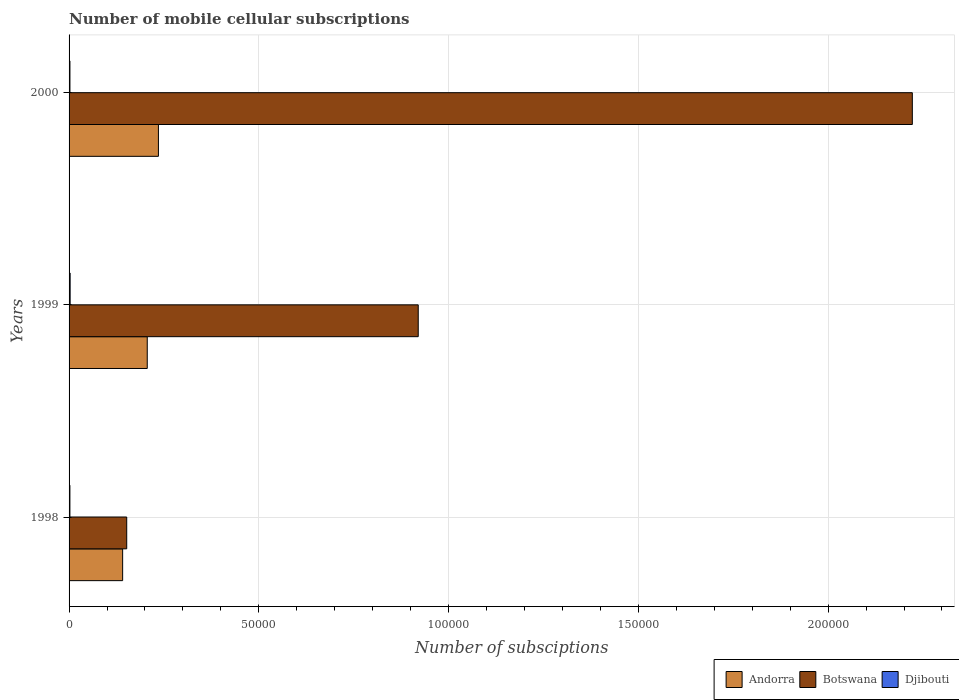How many groups of bars are there?
Your answer should be very brief. 3. What is the label of the 3rd group of bars from the top?
Make the answer very short. 1998. In how many cases, is the number of bars for a given year not equal to the number of legend labels?
Make the answer very short. 0. What is the number of mobile cellular subscriptions in Botswana in 1998?
Your answer should be very brief. 1.52e+04. Across all years, what is the maximum number of mobile cellular subscriptions in Botswana?
Your answer should be compact. 2.22e+05. Across all years, what is the minimum number of mobile cellular subscriptions in Botswana?
Make the answer very short. 1.52e+04. What is the total number of mobile cellular subscriptions in Botswana in the graph?
Your response must be concise. 3.29e+05. What is the difference between the number of mobile cellular subscriptions in Djibouti in 1998 and that in 2000?
Your response must be concise. -10. What is the difference between the number of mobile cellular subscriptions in Andorra in 2000 and the number of mobile cellular subscriptions in Djibouti in 1998?
Provide a short and direct response. 2.33e+04. What is the average number of mobile cellular subscriptions in Botswana per year?
Provide a short and direct response. 1.10e+05. In the year 2000, what is the difference between the number of mobile cellular subscriptions in Djibouti and number of mobile cellular subscriptions in Botswana?
Provide a short and direct response. -2.22e+05. What is the ratio of the number of mobile cellular subscriptions in Andorra in 1998 to that in 2000?
Ensure brevity in your answer.  0.6. Is the difference between the number of mobile cellular subscriptions in Djibouti in 1998 and 1999 greater than the difference between the number of mobile cellular subscriptions in Botswana in 1998 and 1999?
Provide a short and direct response. Yes. What is the difference between the highest and the second highest number of mobile cellular subscriptions in Botswana?
Give a very brief answer. 1.30e+05. What is the difference between the highest and the lowest number of mobile cellular subscriptions in Botswana?
Your response must be concise. 2.07e+05. What does the 3rd bar from the top in 2000 represents?
Offer a terse response. Andorra. What does the 1st bar from the bottom in 1999 represents?
Your response must be concise. Andorra. What is the difference between two consecutive major ticks on the X-axis?
Offer a terse response. 5.00e+04. Are the values on the major ticks of X-axis written in scientific E-notation?
Provide a short and direct response. No. What is the title of the graph?
Ensure brevity in your answer.  Number of mobile cellular subscriptions. What is the label or title of the X-axis?
Provide a succinct answer. Number of subsciptions. What is the Number of subsciptions of Andorra in 1998?
Your answer should be very brief. 1.41e+04. What is the Number of subsciptions of Botswana in 1998?
Offer a terse response. 1.52e+04. What is the Number of subsciptions in Djibouti in 1998?
Offer a terse response. 220. What is the Number of subsciptions in Andorra in 1999?
Provide a short and direct response. 2.06e+04. What is the Number of subsciptions in Botswana in 1999?
Your answer should be very brief. 9.20e+04. What is the Number of subsciptions of Djibouti in 1999?
Make the answer very short. 280. What is the Number of subsciptions in Andorra in 2000?
Make the answer very short. 2.35e+04. What is the Number of subsciptions of Botswana in 2000?
Offer a terse response. 2.22e+05. What is the Number of subsciptions of Djibouti in 2000?
Offer a terse response. 230. Across all years, what is the maximum Number of subsciptions in Andorra?
Give a very brief answer. 2.35e+04. Across all years, what is the maximum Number of subsciptions of Botswana?
Your response must be concise. 2.22e+05. Across all years, what is the maximum Number of subsciptions in Djibouti?
Provide a succinct answer. 280. Across all years, what is the minimum Number of subsciptions of Andorra?
Your answer should be very brief. 1.41e+04. Across all years, what is the minimum Number of subsciptions in Botswana?
Give a very brief answer. 1.52e+04. Across all years, what is the minimum Number of subsciptions in Djibouti?
Provide a short and direct response. 220. What is the total Number of subsciptions in Andorra in the graph?
Offer a very short reply. 5.83e+04. What is the total Number of subsciptions of Botswana in the graph?
Offer a terse response. 3.29e+05. What is the total Number of subsciptions of Djibouti in the graph?
Offer a very short reply. 730. What is the difference between the Number of subsciptions of Andorra in 1998 and that in 1999?
Ensure brevity in your answer.  -6483. What is the difference between the Number of subsciptions of Botswana in 1998 and that in 1999?
Your answer should be very brief. -7.68e+04. What is the difference between the Number of subsciptions of Djibouti in 1998 and that in 1999?
Provide a short and direct response. -60. What is the difference between the Number of subsciptions in Andorra in 1998 and that in 2000?
Your answer should be very brief. -9426. What is the difference between the Number of subsciptions of Botswana in 1998 and that in 2000?
Offer a very short reply. -2.07e+05. What is the difference between the Number of subsciptions in Andorra in 1999 and that in 2000?
Your answer should be compact. -2943. What is the difference between the Number of subsciptions of Botswana in 1999 and that in 2000?
Offer a very short reply. -1.30e+05. What is the difference between the Number of subsciptions of Djibouti in 1999 and that in 2000?
Offer a terse response. 50. What is the difference between the Number of subsciptions of Andorra in 1998 and the Number of subsciptions of Botswana in 1999?
Make the answer very short. -7.79e+04. What is the difference between the Number of subsciptions in Andorra in 1998 and the Number of subsciptions in Djibouti in 1999?
Your answer should be compact. 1.38e+04. What is the difference between the Number of subsciptions of Botswana in 1998 and the Number of subsciptions of Djibouti in 1999?
Make the answer very short. 1.49e+04. What is the difference between the Number of subsciptions of Andorra in 1998 and the Number of subsciptions of Botswana in 2000?
Give a very brief answer. -2.08e+05. What is the difference between the Number of subsciptions in Andorra in 1998 and the Number of subsciptions in Djibouti in 2000?
Your response must be concise. 1.39e+04. What is the difference between the Number of subsciptions of Botswana in 1998 and the Number of subsciptions of Djibouti in 2000?
Offer a very short reply. 1.50e+04. What is the difference between the Number of subsciptions of Andorra in 1999 and the Number of subsciptions of Botswana in 2000?
Your answer should be very brief. -2.02e+05. What is the difference between the Number of subsciptions of Andorra in 1999 and the Number of subsciptions of Djibouti in 2000?
Provide a short and direct response. 2.04e+04. What is the difference between the Number of subsciptions of Botswana in 1999 and the Number of subsciptions of Djibouti in 2000?
Give a very brief answer. 9.18e+04. What is the average Number of subsciptions in Andorra per year?
Provide a short and direct response. 1.94e+04. What is the average Number of subsciptions of Botswana per year?
Your answer should be very brief. 1.10e+05. What is the average Number of subsciptions in Djibouti per year?
Offer a very short reply. 243.33. In the year 1998, what is the difference between the Number of subsciptions of Andorra and Number of subsciptions of Botswana?
Keep it short and to the point. -1073. In the year 1998, what is the difference between the Number of subsciptions of Andorra and Number of subsciptions of Djibouti?
Offer a terse response. 1.39e+04. In the year 1998, what is the difference between the Number of subsciptions of Botswana and Number of subsciptions of Djibouti?
Provide a short and direct response. 1.50e+04. In the year 1999, what is the difference between the Number of subsciptions of Andorra and Number of subsciptions of Botswana?
Your answer should be compact. -7.14e+04. In the year 1999, what is the difference between the Number of subsciptions of Andorra and Number of subsciptions of Djibouti?
Offer a very short reply. 2.03e+04. In the year 1999, what is the difference between the Number of subsciptions in Botswana and Number of subsciptions in Djibouti?
Offer a terse response. 9.17e+04. In the year 2000, what is the difference between the Number of subsciptions of Andorra and Number of subsciptions of Botswana?
Give a very brief answer. -1.99e+05. In the year 2000, what is the difference between the Number of subsciptions of Andorra and Number of subsciptions of Djibouti?
Give a very brief answer. 2.33e+04. In the year 2000, what is the difference between the Number of subsciptions in Botswana and Number of subsciptions in Djibouti?
Give a very brief answer. 2.22e+05. What is the ratio of the Number of subsciptions of Andorra in 1998 to that in 1999?
Make the answer very short. 0.69. What is the ratio of the Number of subsciptions of Botswana in 1998 to that in 1999?
Offer a terse response. 0.17. What is the ratio of the Number of subsciptions of Djibouti in 1998 to that in 1999?
Keep it short and to the point. 0.79. What is the ratio of the Number of subsciptions of Andorra in 1998 to that in 2000?
Make the answer very short. 0.6. What is the ratio of the Number of subsciptions of Botswana in 1998 to that in 2000?
Provide a short and direct response. 0.07. What is the ratio of the Number of subsciptions of Djibouti in 1998 to that in 2000?
Keep it short and to the point. 0.96. What is the ratio of the Number of subsciptions in Andorra in 1999 to that in 2000?
Ensure brevity in your answer.  0.88. What is the ratio of the Number of subsciptions of Botswana in 1999 to that in 2000?
Offer a terse response. 0.41. What is the ratio of the Number of subsciptions of Djibouti in 1999 to that in 2000?
Offer a very short reply. 1.22. What is the difference between the highest and the second highest Number of subsciptions in Andorra?
Offer a terse response. 2943. What is the difference between the highest and the second highest Number of subsciptions in Botswana?
Make the answer very short. 1.30e+05. What is the difference between the highest and the second highest Number of subsciptions in Djibouti?
Provide a short and direct response. 50. What is the difference between the highest and the lowest Number of subsciptions in Andorra?
Your answer should be very brief. 9426. What is the difference between the highest and the lowest Number of subsciptions of Botswana?
Your response must be concise. 2.07e+05. What is the difference between the highest and the lowest Number of subsciptions in Djibouti?
Offer a terse response. 60. 